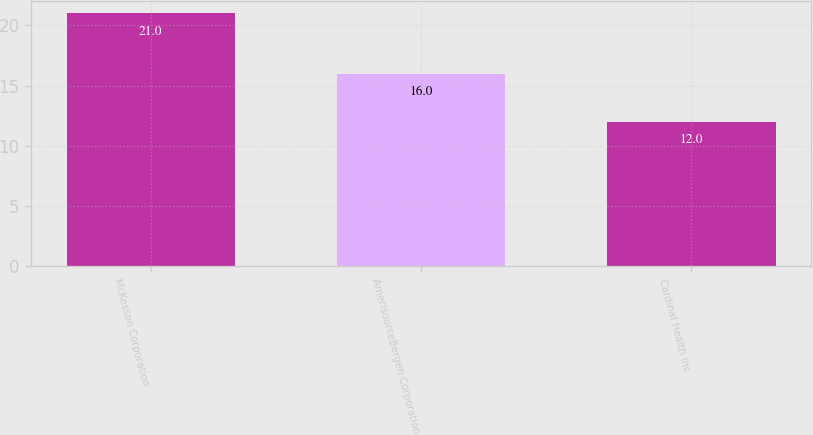Convert chart to OTSL. <chart><loc_0><loc_0><loc_500><loc_500><bar_chart><fcel>McKesson Corporation<fcel>AmerisourceBergen Corporation<fcel>Cardinal Health Inc<nl><fcel>21<fcel>16<fcel>12<nl></chart> 